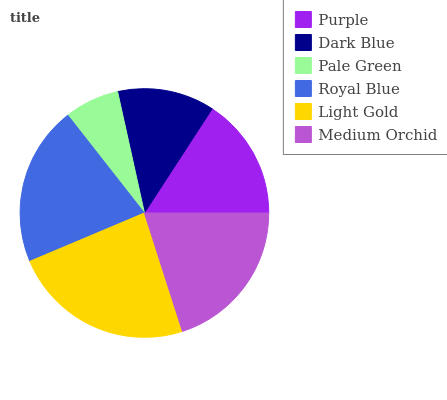Is Pale Green the minimum?
Answer yes or no. Yes. Is Light Gold the maximum?
Answer yes or no. Yes. Is Dark Blue the minimum?
Answer yes or no. No. Is Dark Blue the maximum?
Answer yes or no. No. Is Purple greater than Dark Blue?
Answer yes or no. Yes. Is Dark Blue less than Purple?
Answer yes or no. Yes. Is Dark Blue greater than Purple?
Answer yes or no. No. Is Purple less than Dark Blue?
Answer yes or no. No. Is Medium Orchid the high median?
Answer yes or no. Yes. Is Purple the low median?
Answer yes or no. Yes. Is Light Gold the high median?
Answer yes or no. No. Is Royal Blue the low median?
Answer yes or no. No. 